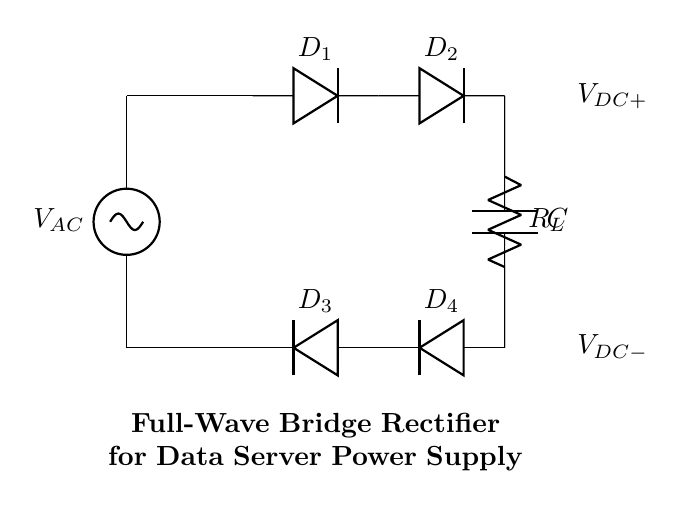What is the type of rectifier shown in this circuit? The circuit is a full-wave bridge rectifier, which is characterized by using four diodes arranged in a bridge configuration to convert the entire AC waveform into DC.
Answer: Full-wave bridge rectifier How many diodes are in the circuit? The circuit diagram clearly shows four diodes labeled as D1, D2, D3, and D4, confirming the presence of four diodes necessary for full-wave rectification.
Answer: Four What component smoothens the output voltage? The capacitor, labeled C in the circuit, acts to smooth out the output voltage by charging and discharging, thereby reducing ripple in the DC output.
Answer: Capacitor What is the purpose of the load resistor? The load resistor, indicated as R_L, serves to provide a load for the output voltage, allowing current to flow through and enabling the power supply to deliver energy to the connected load, simulating practical use.
Answer: Load resistor What is the output voltage labeling in the circuit? The circuit specifies the output voltage with labels V_DC+ and V_DC-, representing the positive and negative output terminals of the rectifier.
Answer: V_DC+ and V_DC- What is the input voltage source type for this circuit? The circuit has an AC voltage source labeled as V_AC, indicating that it takes alternating current as input to be converted into direct current via the rectifier.
Answer: AC voltage source 